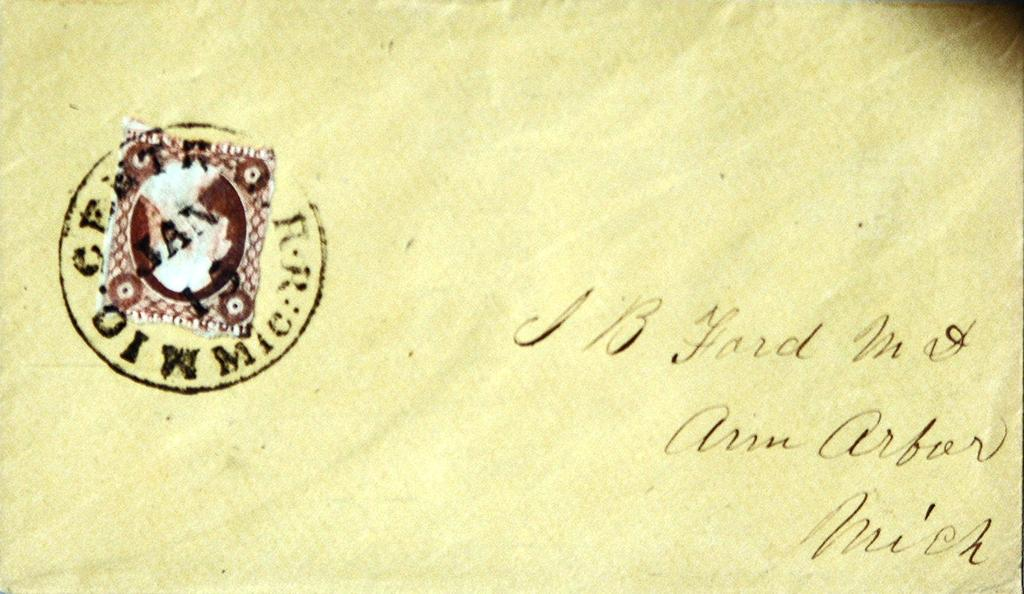Provide a one-sentence caption for the provided image. yellow envelope addressed to J B ford in Ann Arbor Michigan. 